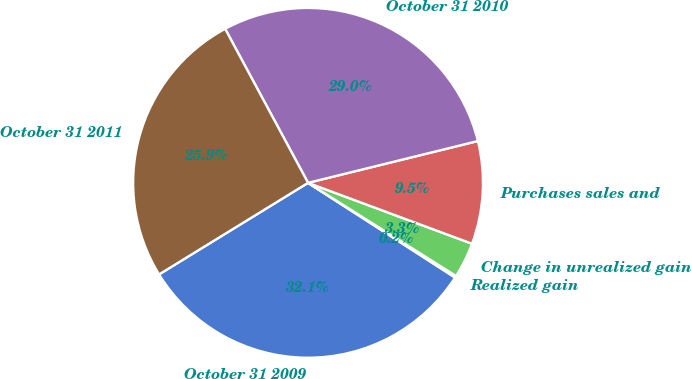<chart> <loc_0><loc_0><loc_500><loc_500><pie_chart><fcel>October 31 2009<fcel>Realized gain<fcel>Change in unrealized gain<fcel>Purchases sales and<fcel>October 31 2010<fcel>October 31 2011<nl><fcel>32.12%<fcel>0.17%<fcel>3.28%<fcel>9.5%<fcel>29.02%<fcel>25.91%<nl></chart> 